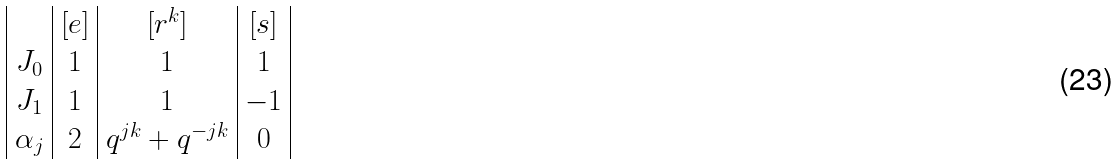<formula> <loc_0><loc_0><loc_500><loc_500>\begin{array} { | c | c | c | c | } & [ e ] & [ r ^ { k } ] & [ s ] \\ J _ { 0 } & 1 & 1 & 1 \\ J _ { 1 } & 1 & 1 & - 1 \\ \alpha _ { j } & 2 & q ^ { j k } + q ^ { - j k } & 0 \\ \end{array}</formula> 